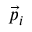<formula> <loc_0><loc_0><loc_500><loc_500>{ \vec { p } } _ { i }</formula> 